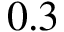Convert formula to latex. <formula><loc_0><loc_0><loc_500><loc_500>0 . 3</formula> 